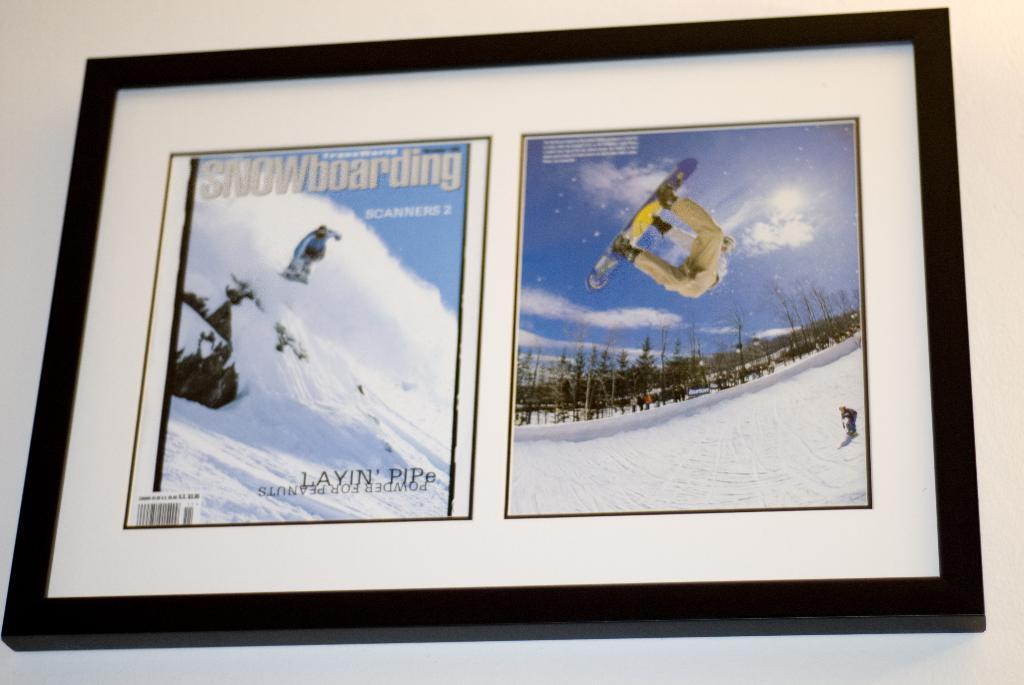Provide a one-sentence caption for the provided image. A framed copy of Snowboarding Magazine with the image of a person on a snowboard doing a flip. 